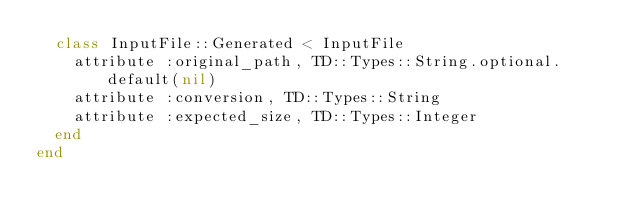<code> <loc_0><loc_0><loc_500><loc_500><_Ruby_>  class InputFile::Generated < InputFile
    attribute :original_path, TD::Types::String.optional.default(nil)
    attribute :conversion, TD::Types::String
    attribute :expected_size, TD::Types::Integer
  end
end
</code> 